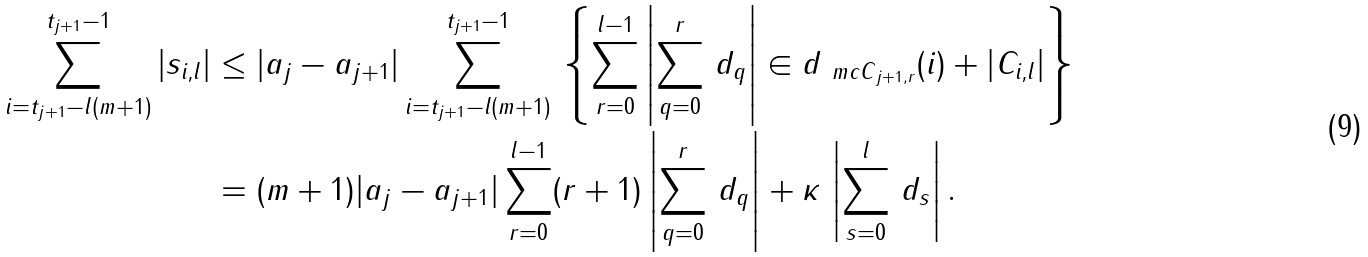Convert formula to latex. <formula><loc_0><loc_0><loc_500><loc_500>\sum _ { i = t _ { j + 1 } - l ( m + 1 ) } ^ { t _ { j + 1 } - 1 } | s _ { i , l } | & \leq | a _ { j } - a _ { j + 1 } | \sum _ { i = t _ { j + 1 } - l ( m + 1 ) } ^ { t _ { j + 1 } - 1 } \, \left \{ \sum _ { r = 0 } ^ { l - 1 } \left | \sum _ { q = 0 } ^ { r } \, d _ { q } \right | \in d _ { { \ m c C } _ { j + 1 , r } } ( i ) + \left | C _ { i , l } \right | \right \} \\ & = ( m + 1 ) | a _ { j } - a _ { j + 1 } | \sum _ { r = 0 } ^ { l - 1 } ( r + 1 ) \left | \sum _ { q = 0 } ^ { r } \, d _ { q } \right | + \kappa \, \left | \sum _ { s = 0 } ^ { l } \, d _ { s } \right | .</formula> 